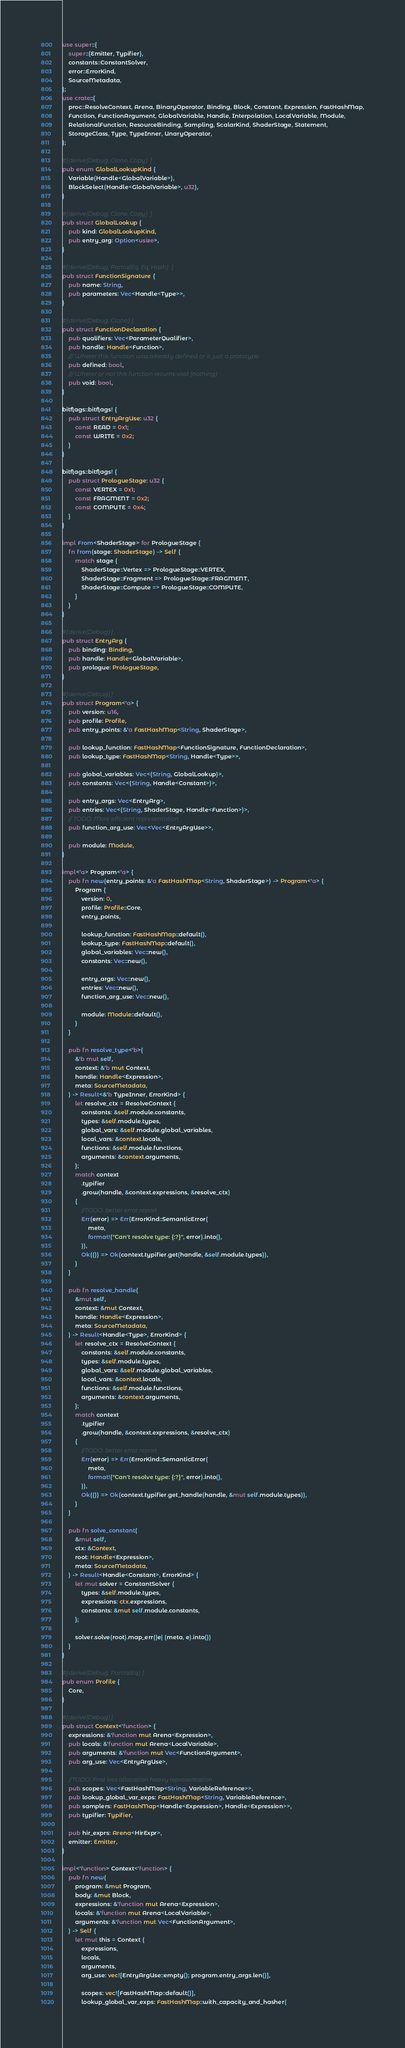Convert code to text. <code><loc_0><loc_0><loc_500><loc_500><_Rust_>use super::{
    super::{Emitter, Typifier},
    constants::ConstantSolver,
    error::ErrorKind,
    SourceMetadata,
};
use crate::{
    proc::ResolveContext, Arena, BinaryOperator, Binding, Block, Constant, Expression, FastHashMap,
    Function, FunctionArgument, GlobalVariable, Handle, Interpolation, LocalVariable, Module,
    RelationalFunction, ResourceBinding, Sampling, ScalarKind, ShaderStage, Statement,
    StorageClass, Type, TypeInner, UnaryOperator,
};

#[derive(Debug, Clone, Copy)]
pub enum GlobalLookupKind {
    Variable(Handle<GlobalVariable>),
    BlockSelect(Handle<GlobalVariable>, u32),
}

#[derive(Debug, Clone, Copy)]
pub struct GlobalLookup {
    pub kind: GlobalLookupKind,
    pub entry_arg: Option<usize>,
}

#[derive(Debug, PartialEq, Eq, Hash)]
pub struct FunctionSignature {
    pub name: String,
    pub parameters: Vec<Handle<Type>>,
}

#[derive(Debug, Clone)]
pub struct FunctionDeclaration {
    pub qualifiers: Vec<ParameterQualifier>,
    pub handle: Handle<Function>,
    /// Wheter this function was already defined or is just a prototype
    pub defined: bool,
    /// Wheter or not this function returns void (nothing)
    pub void: bool,
}

bitflags::bitflags! {
    pub struct EntryArgUse: u32 {
        const READ = 0x1;
        const WRITE = 0x2;
    }
}

bitflags::bitflags! {
    pub struct PrologueStage: u32 {
        const VERTEX = 0x1;
        const FRAGMENT = 0x2;
        const COMPUTE = 0x4;
    }
}

impl From<ShaderStage> for PrologueStage {
    fn from(stage: ShaderStage) -> Self {
        match stage {
            ShaderStage::Vertex => PrologueStage::VERTEX,
            ShaderStage::Fragment => PrologueStage::FRAGMENT,
            ShaderStage::Compute => PrologueStage::COMPUTE,
        }
    }
}

#[derive(Debug)]
pub struct EntryArg {
    pub binding: Binding,
    pub handle: Handle<GlobalVariable>,
    pub prologue: PrologueStage,
}

#[derive(Debug)]
pub struct Program<'a> {
    pub version: u16,
    pub profile: Profile,
    pub entry_points: &'a FastHashMap<String, ShaderStage>,

    pub lookup_function: FastHashMap<FunctionSignature, FunctionDeclaration>,
    pub lookup_type: FastHashMap<String, Handle<Type>>,

    pub global_variables: Vec<(String, GlobalLookup)>,
    pub constants: Vec<(String, Handle<Constant>)>,

    pub entry_args: Vec<EntryArg>,
    pub entries: Vec<(String, ShaderStage, Handle<Function>)>,
    // TODO: More efficient representation
    pub function_arg_use: Vec<Vec<EntryArgUse>>,

    pub module: Module,
}

impl<'a> Program<'a> {
    pub fn new(entry_points: &'a FastHashMap<String, ShaderStage>) -> Program<'a> {
        Program {
            version: 0,
            profile: Profile::Core,
            entry_points,

            lookup_function: FastHashMap::default(),
            lookup_type: FastHashMap::default(),
            global_variables: Vec::new(),
            constants: Vec::new(),

            entry_args: Vec::new(),
            entries: Vec::new(),
            function_arg_use: Vec::new(),

            module: Module::default(),
        }
    }

    pub fn resolve_type<'b>(
        &'b mut self,
        context: &'b mut Context,
        handle: Handle<Expression>,
        meta: SourceMetadata,
    ) -> Result<&'b TypeInner, ErrorKind> {
        let resolve_ctx = ResolveContext {
            constants: &self.module.constants,
            types: &self.module.types,
            global_vars: &self.module.global_variables,
            local_vars: &context.locals,
            functions: &self.module.functions,
            arguments: &context.arguments,
        };
        match context
            .typifier
            .grow(handle, &context.expressions, &resolve_ctx)
        {
            //TODO: better error report
            Err(error) => Err(ErrorKind::SemanticError(
                meta,
                format!("Can't resolve type: {:?}", error).into(),
            )),
            Ok(()) => Ok(context.typifier.get(handle, &self.module.types)),
        }
    }

    pub fn resolve_handle(
        &mut self,
        context: &mut Context,
        handle: Handle<Expression>,
        meta: SourceMetadata,
    ) -> Result<Handle<Type>, ErrorKind> {
        let resolve_ctx = ResolveContext {
            constants: &self.module.constants,
            types: &self.module.types,
            global_vars: &self.module.global_variables,
            local_vars: &context.locals,
            functions: &self.module.functions,
            arguments: &context.arguments,
        };
        match context
            .typifier
            .grow(handle, &context.expressions, &resolve_ctx)
        {
            //TODO: better error report
            Err(error) => Err(ErrorKind::SemanticError(
                meta,
                format!("Can't resolve type: {:?}", error).into(),
            )),
            Ok(()) => Ok(context.typifier.get_handle(handle, &mut self.module.types)),
        }
    }

    pub fn solve_constant(
        &mut self,
        ctx: &Context,
        root: Handle<Expression>,
        meta: SourceMetadata,
    ) -> Result<Handle<Constant>, ErrorKind> {
        let mut solver = ConstantSolver {
            types: &self.module.types,
            expressions: ctx.expressions,
            constants: &mut self.module.constants,
        };

        solver.solve(root).map_err(|e| (meta, e).into())
    }
}

#[derive(Debug, PartialEq)]
pub enum Profile {
    Core,
}

#[derive(Debug)]
pub struct Context<'function> {
    expressions: &'function mut Arena<Expression>,
    pub locals: &'function mut Arena<LocalVariable>,
    pub arguments: &'function mut Vec<FunctionArgument>,
    pub arg_use: Vec<EntryArgUse>,

    //TODO: Find less allocation heavy representation
    pub scopes: Vec<FastHashMap<String, VariableReference>>,
    pub lookup_global_var_exps: FastHashMap<String, VariableReference>,
    pub samplers: FastHashMap<Handle<Expression>, Handle<Expression>>,
    pub typifier: Typifier,

    pub hir_exprs: Arena<HirExpr>,
    emitter: Emitter,
}

impl<'function> Context<'function> {
    pub fn new(
        program: &mut Program,
        body: &mut Block,
        expressions: &'function mut Arena<Expression>,
        locals: &'function mut Arena<LocalVariable>,
        arguments: &'function mut Vec<FunctionArgument>,
    ) -> Self {
        let mut this = Context {
            expressions,
            locals,
            arguments,
            arg_use: vec![EntryArgUse::empty(); program.entry_args.len()],

            scopes: vec![FastHashMap::default()],
            lookup_global_var_exps: FastHashMap::with_capacity_and_hasher(</code> 